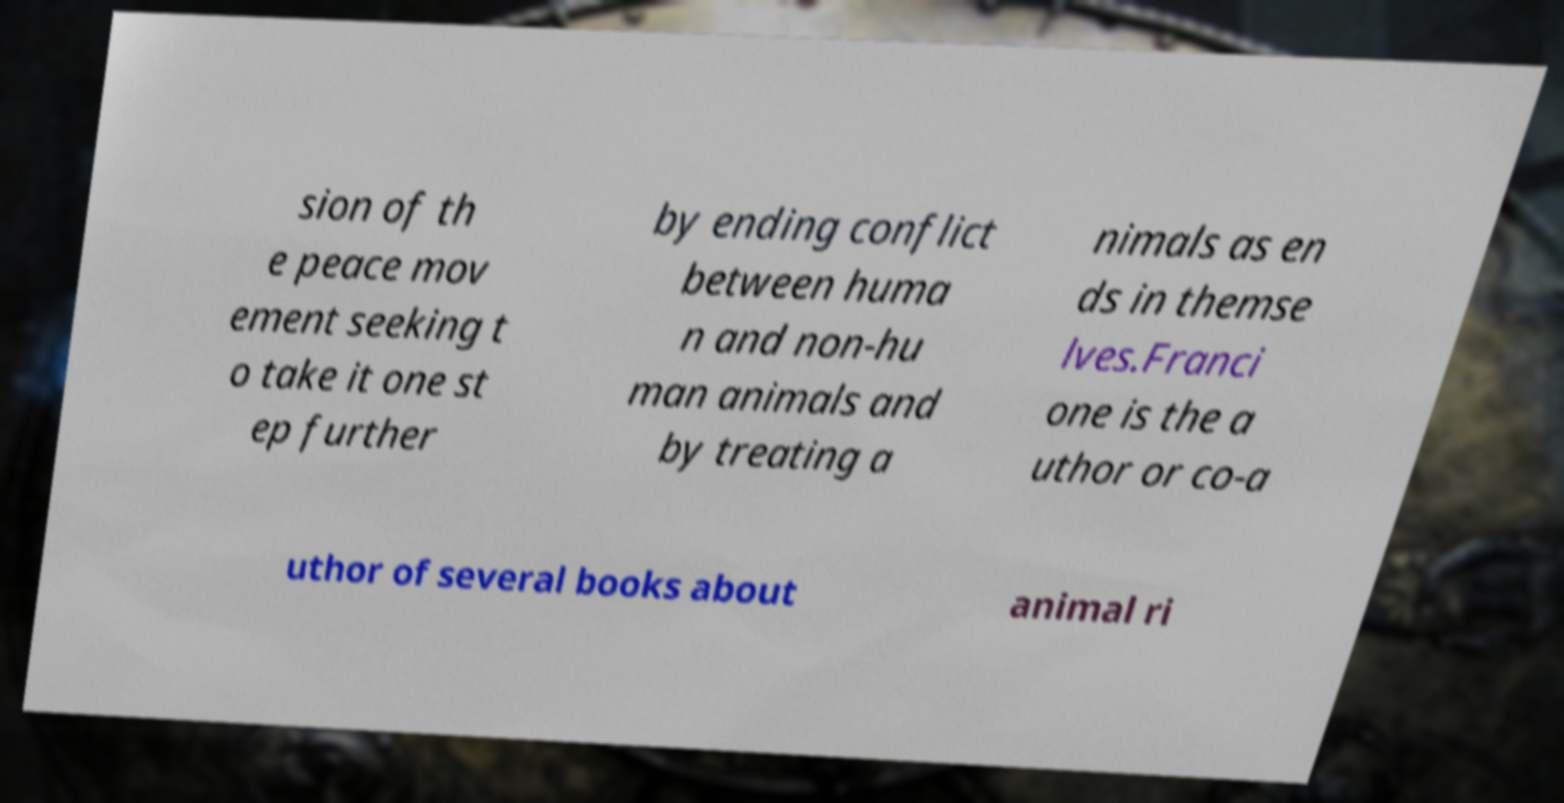For documentation purposes, I need the text within this image transcribed. Could you provide that? sion of th e peace mov ement seeking t o take it one st ep further by ending conflict between huma n and non-hu man animals and by treating a nimals as en ds in themse lves.Franci one is the a uthor or co-a uthor of several books about animal ri 